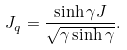Convert formula to latex. <formula><loc_0><loc_0><loc_500><loc_500>J _ { q } = \frac { \sinh \gamma J } { \sqrt { \gamma \sinh \gamma } } .</formula> 